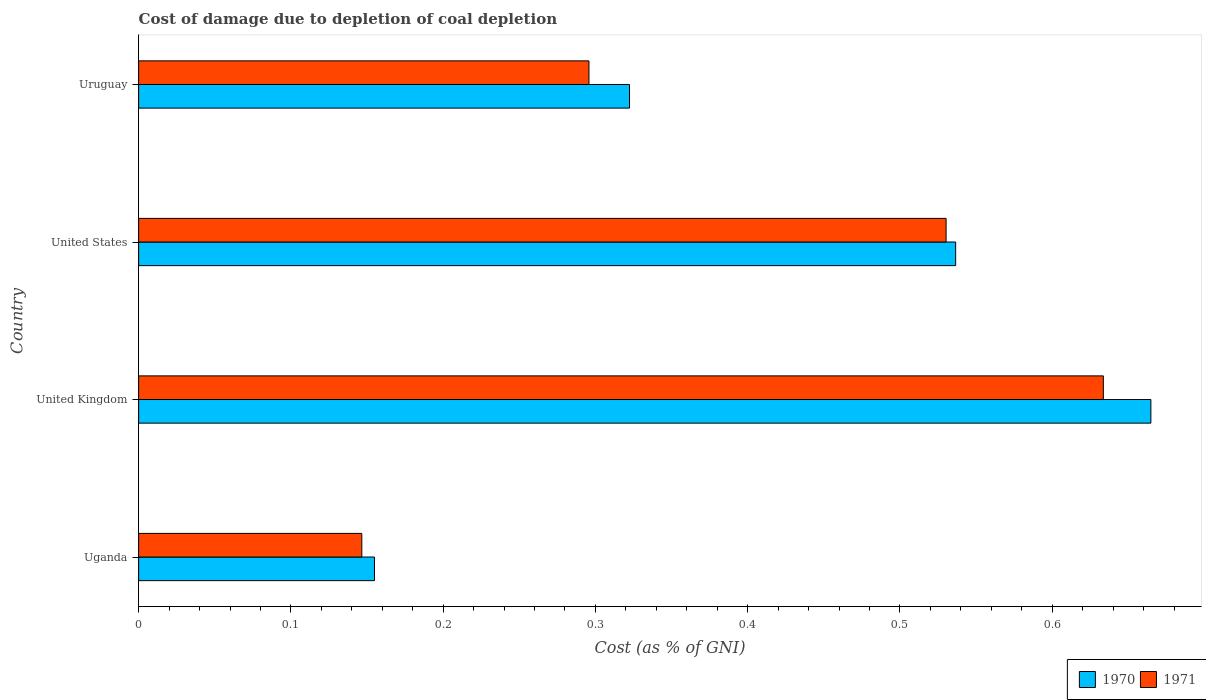Are the number of bars on each tick of the Y-axis equal?
Ensure brevity in your answer.  Yes. How many bars are there on the 2nd tick from the bottom?
Your response must be concise. 2. What is the label of the 2nd group of bars from the top?
Provide a succinct answer. United States. What is the cost of damage caused due to coal depletion in 1971 in Uganda?
Provide a succinct answer. 0.15. Across all countries, what is the maximum cost of damage caused due to coal depletion in 1971?
Your answer should be very brief. 0.63. Across all countries, what is the minimum cost of damage caused due to coal depletion in 1970?
Offer a very short reply. 0.15. In which country was the cost of damage caused due to coal depletion in 1970 maximum?
Your answer should be very brief. United Kingdom. In which country was the cost of damage caused due to coal depletion in 1970 minimum?
Make the answer very short. Uganda. What is the total cost of damage caused due to coal depletion in 1971 in the graph?
Your response must be concise. 1.61. What is the difference between the cost of damage caused due to coal depletion in 1970 in United Kingdom and that in United States?
Ensure brevity in your answer.  0.13. What is the difference between the cost of damage caused due to coal depletion in 1971 in Uruguay and the cost of damage caused due to coal depletion in 1970 in United Kingdom?
Keep it short and to the point. -0.37. What is the average cost of damage caused due to coal depletion in 1970 per country?
Your answer should be very brief. 0.42. What is the difference between the cost of damage caused due to coal depletion in 1971 and cost of damage caused due to coal depletion in 1970 in United Kingdom?
Make the answer very short. -0.03. What is the ratio of the cost of damage caused due to coal depletion in 1970 in Uganda to that in United Kingdom?
Offer a terse response. 0.23. Is the cost of damage caused due to coal depletion in 1971 in United Kingdom less than that in Uruguay?
Offer a very short reply. No. Is the difference between the cost of damage caused due to coal depletion in 1971 in Uganda and Uruguay greater than the difference between the cost of damage caused due to coal depletion in 1970 in Uganda and Uruguay?
Keep it short and to the point. Yes. What is the difference between the highest and the second highest cost of damage caused due to coal depletion in 1970?
Your response must be concise. 0.13. What is the difference between the highest and the lowest cost of damage caused due to coal depletion in 1971?
Provide a short and direct response. 0.49. What does the 2nd bar from the top in Uruguay represents?
Offer a terse response. 1970. What does the 1st bar from the bottom in United Kingdom represents?
Provide a succinct answer. 1970. How many bars are there?
Your answer should be compact. 8. Are all the bars in the graph horizontal?
Give a very brief answer. Yes. What is the difference between two consecutive major ticks on the X-axis?
Offer a very short reply. 0.1. Does the graph contain any zero values?
Make the answer very short. No. How are the legend labels stacked?
Provide a succinct answer. Horizontal. What is the title of the graph?
Offer a very short reply. Cost of damage due to depletion of coal depletion. Does "1980" appear as one of the legend labels in the graph?
Give a very brief answer. No. What is the label or title of the X-axis?
Provide a short and direct response. Cost (as % of GNI). What is the label or title of the Y-axis?
Provide a short and direct response. Country. What is the Cost (as % of GNI) of 1970 in Uganda?
Your answer should be compact. 0.15. What is the Cost (as % of GNI) in 1971 in Uganda?
Ensure brevity in your answer.  0.15. What is the Cost (as % of GNI) in 1970 in United Kingdom?
Offer a very short reply. 0.66. What is the Cost (as % of GNI) in 1971 in United Kingdom?
Give a very brief answer. 0.63. What is the Cost (as % of GNI) in 1970 in United States?
Your response must be concise. 0.54. What is the Cost (as % of GNI) in 1971 in United States?
Your response must be concise. 0.53. What is the Cost (as % of GNI) of 1970 in Uruguay?
Offer a terse response. 0.32. What is the Cost (as % of GNI) in 1971 in Uruguay?
Offer a very short reply. 0.3. Across all countries, what is the maximum Cost (as % of GNI) in 1970?
Offer a terse response. 0.66. Across all countries, what is the maximum Cost (as % of GNI) in 1971?
Your answer should be compact. 0.63. Across all countries, what is the minimum Cost (as % of GNI) of 1970?
Ensure brevity in your answer.  0.15. Across all countries, what is the minimum Cost (as % of GNI) in 1971?
Your answer should be compact. 0.15. What is the total Cost (as % of GNI) in 1970 in the graph?
Your response must be concise. 1.68. What is the total Cost (as % of GNI) in 1971 in the graph?
Provide a short and direct response. 1.61. What is the difference between the Cost (as % of GNI) of 1970 in Uganda and that in United Kingdom?
Offer a very short reply. -0.51. What is the difference between the Cost (as % of GNI) in 1971 in Uganda and that in United Kingdom?
Keep it short and to the point. -0.49. What is the difference between the Cost (as % of GNI) in 1970 in Uganda and that in United States?
Ensure brevity in your answer.  -0.38. What is the difference between the Cost (as % of GNI) in 1971 in Uganda and that in United States?
Make the answer very short. -0.38. What is the difference between the Cost (as % of GNI) in 1970 in Uganda and that in Uruguay?
Your response must be concise. -0.17. What is the difference between the Cost (as % of GNI) in 1971 in Uganda and that in Uruguay?
Provide a succinct answer. -0.15. What is the difference between the Cost (as % of GNI) in 1970 in United Kingdom and that in United States?
Offer a very short reply. 0.13. What is the difference between the Cost (as % of GNI) of 1971 in United Kingdom and that in United States?
Offer a terse response. 0.1. What is the difference between the Cost (as % of GNI) of 1970 in United Kingdom and that in Uruguay?
Ensure brevity in your answer.  0.34. What is the difference between the Cost (as % of GNI) in 1971 in United Kingdom and that in Uruguay?
Provide a short and direct response. 0.34. What is the difference between the Cost (as % of GNI) of 1970 in United States and that in Uruguay?
Offer a very short reply. 0.21. What is the difference between the Cost (as % of GNI) of 1971 in United States and that in Uruguay?
Keep it short and to the point. 0.23. What is the difference between the Cost (as % of GNI) of 1970 in Uganda and the Cost (as % of GNI) of 1971 in United Kingdom?
Provide a succinct answer. -0.48. What is the difference between the Cost (as % of GNI) of 1970 in Uganda and the Cost (as % of GNI) of 1971 in United States?
Offer a terse response. -0.38. What is the difference between the Cost (as % of GNI) in 1970 in Uganda and the Cost (as % of GNI) in 1971 in Uruguay?
Offer a terse response. -0.14. What is the difference between the Cost (as % of GNI) in 1970 in United Kingdom and the Cost (as % of GNI) in 1971 in United States?
Provide a succinct answer. 0.13. What is the difference between the Cost (as % of GNI) of 1970 in United Kingdom and the Cost (as % of GNI) of 1971 in Uruguay?
Make the answer very short. 0.37. What is the difference between the Cost (as % of GNI) of 1970 in United States and the Cost (as % of GNI) of 1971 in Uruguay?
Ensure brevity in your answer.  0.24. What is the average Cost (as % of GNI) of 1970 per country?
Your answer should be very brief. 0.42. What is the average Cost (as % of GNI) of 1971 per country?
Offer a very short reply. 0.4. What is the difference between the Cost (as % of GNI) of 1970 and Cost (as % of GNI) of 1971 in Uganda?
Offer a very short reply. 0.01. What is the difference between the Cost (as % of GNI) of 1970 and Cost (as % of GNI) of 1971 in United Kingdom?
Provide a succinct answer. 0.03. What is the difference between the Cost (as % of GNI) of 1970 and Cost (as % of GNI) of 1971 in United States?
Give a very brief answer. 0.01. What is the difference between the Cost (as % of GNI) of 1970 and Cost (as % of GNI) of 1971 in Uruguay?
Your response must be concise. 0.03. What is the ratio of the Cost (as % of GNI) in 1970 in Uganda to that in United Kingdom?
Your response must be concise. 0.23. What is the ratio of the Cost (as % of GNI) in 1971 in Uganda to that in United Kingdom?
Offer a very short reply. 0.23. What is the ratio of the Cost (as % of GNI) in 1970 in Uganda to that in United States?
Ensure brevity in your answer.  0.29. What is the ratio of the Cost (as % of GNI) in 1971 in Uganda to that in United States?
Offer a very short reply. 0.28. What is the ratio of the Cost (as % of GNI) in 1970 in Uganda to that in Uruguay?
Offer a terse response. 0.48. What is the ratio of the Cost (as % of GNI) of 1971 in Uganda to that in Uruguay?
Provide a short and direct response. 0.5. What is the ratio of the Cost (as % of GNI) in 1970 in United Kingdom to that in United States?
Your response must be concise. 1.24. What is the ratio of the Cost (as % of GNI) of 1971 in United Kingdom to that in United States?
Give a very brief answer. 1.19. What is the ratio of the Cost (as % of GNI) of 1970 in United Kingdom to that in Uruguay?
Keep it short and to the point. 2.06. What is the ratio of the Cost (as % of GNI) of 1971 in United Kingdom to that in Uruguay?
Provide a succinct answer. 2.14. What is the ratio of the Cost (as % of GNI) of 1970 in United States to that in Uruguay?
Offer a terse response. 1.66. What is the ratio of the Cost (as % of GNI) of 1971 in United States to that in Uruguay?
Ensure brevity in your answer.  1.79. What is the difference between the highest and the second highest Cost (as % of GNI) in 1970?
Provide a succinct answer. 0.13. What is the difference between the highest and the second highest Cost (as % of GNI) in 1971?
Give a very brief answer. 0.1. What is the difference between the highest and the lowest Cost (as % of GNI) in 1970?
Give a very brief answer. 0.51. What is the difference between the highest and the lowest Cost (as % of GNI) of 1971?
Offer a terse response. 0.49. 